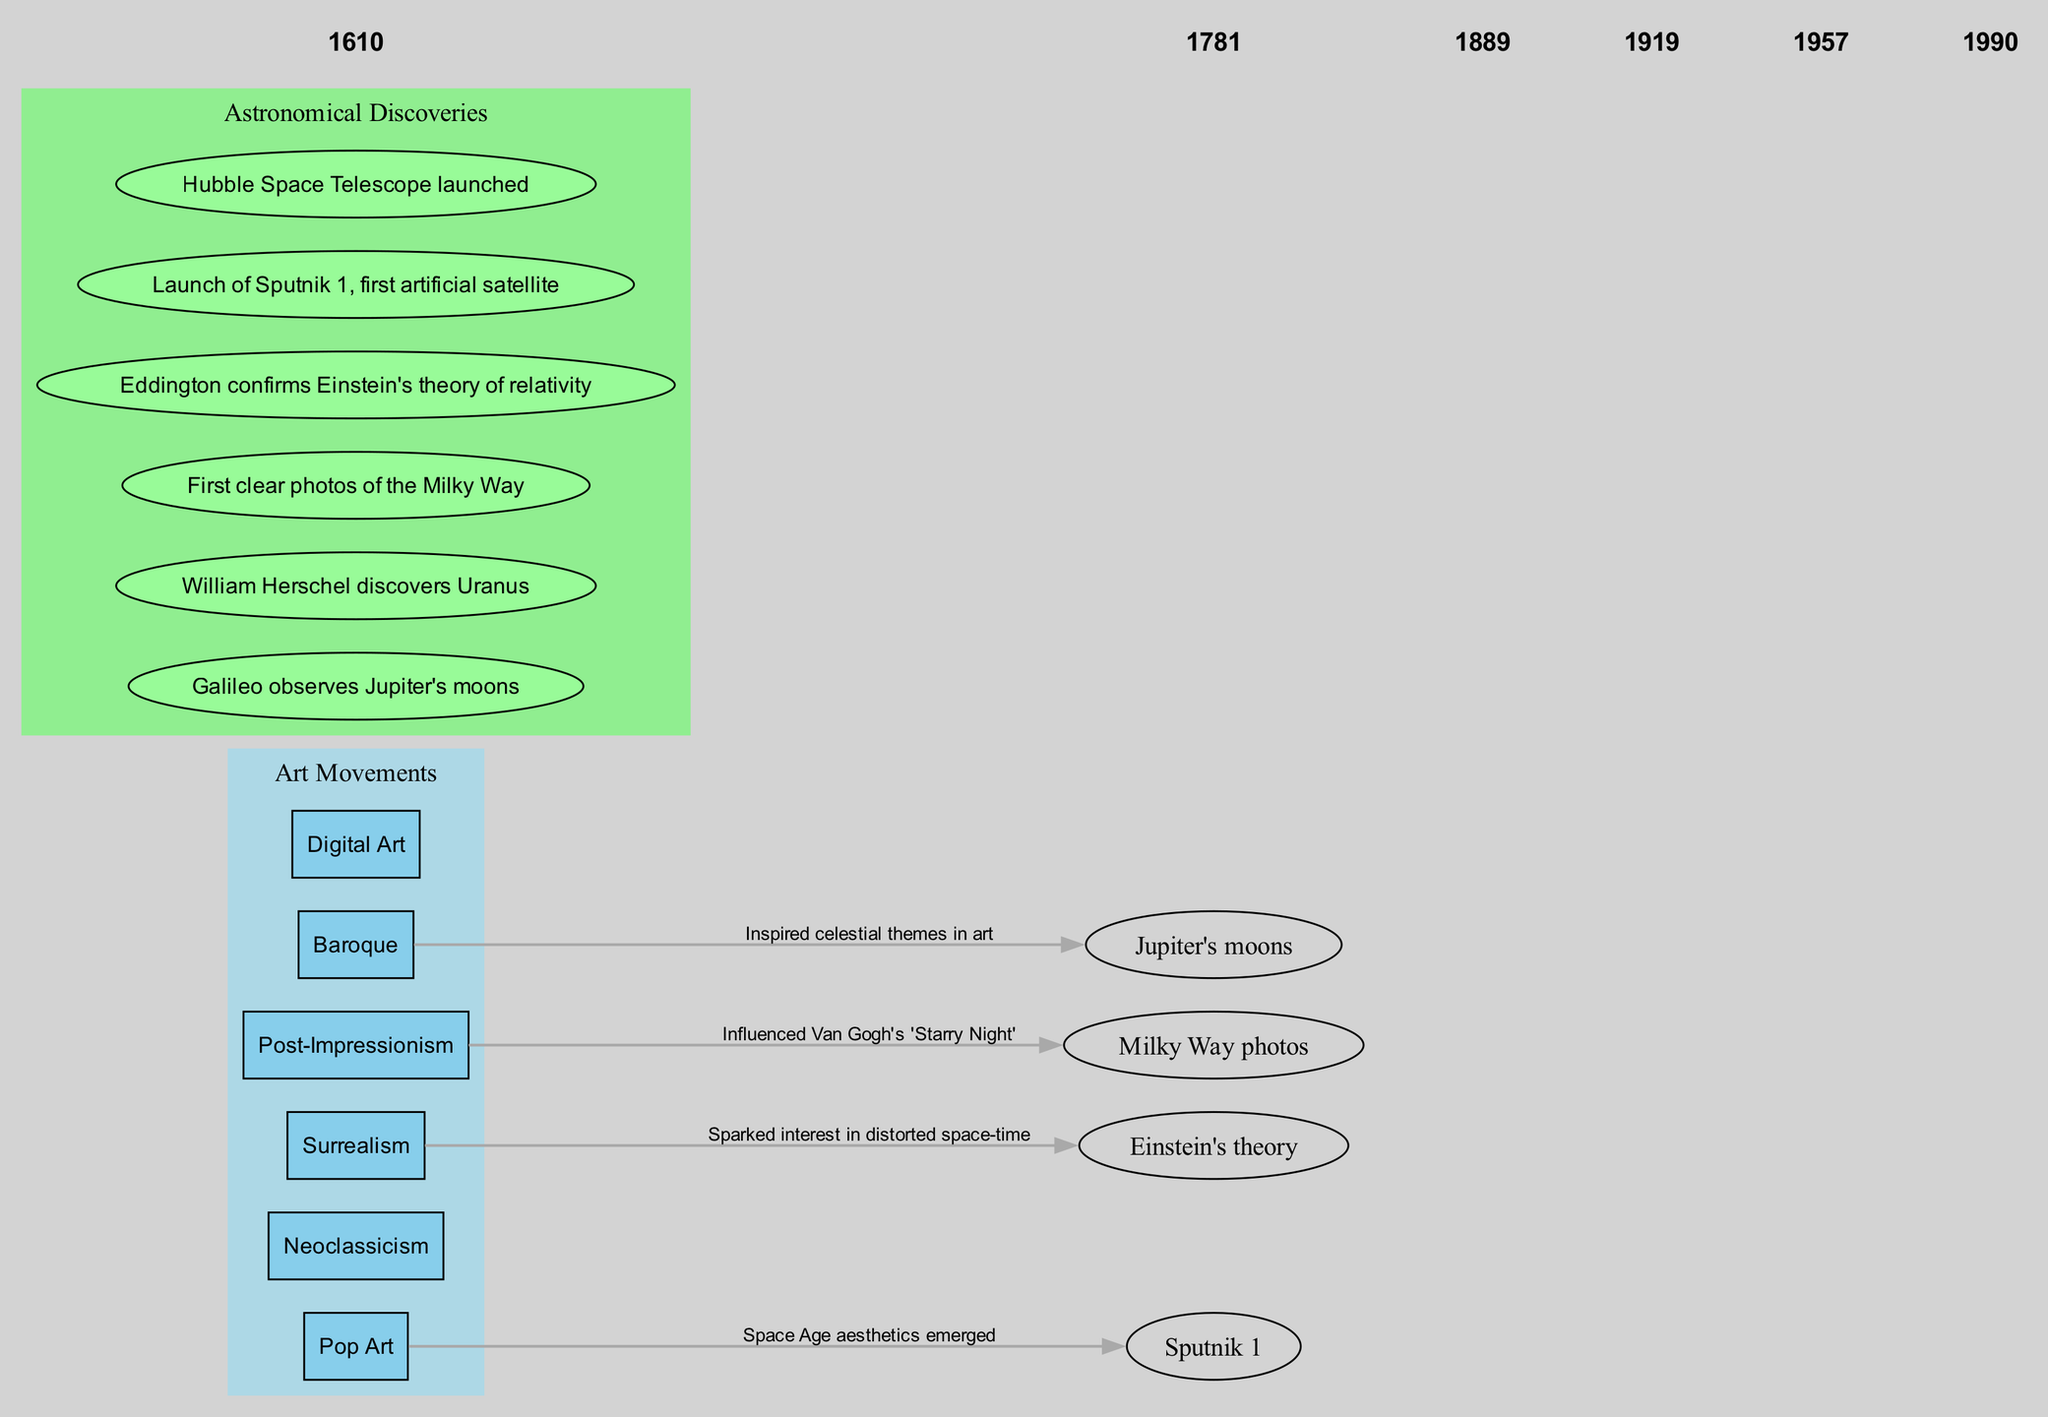What two astronomical discoveries are linked to Neoclassicism? By examining the connections in the diagram, we see that Neoclassicism is connected to the discovery of Uranus in 1781. There are no other discoveries linked to Neoclassicism in the timeline.
Answer: Uranus How many art movements are depicted in the diagram? The diagram lists six art movements: Baroque, Neoclassicism, Post-Impressionism, Surrealism, Pop Art, and Digital Art. By counting each movement from the timeline nodes, we find the total.
Answer: 6 What is the first astronomical discovery shown in the diagram? Looking at the timeline, the first year listed is 1610, which corresponds to Galileo observing Jupiter's moons. This is the earliest discovery mentioned.
Answer: Galileo observes Jupiter's moons Which art movement is associated with the launch of Sputnik 1? The connection indicates that Pop Art is associated with the launch of Sputnik 1 in 1957. This can be confirmed by locating the respective nodes in the diagram.
Answer: Pop Art Why does Post-Impressionism influence Van Gogh's 'Starry Night'? The diagram connects Post-Impressionism with the first clear photos of the Milky Way and suggests that this inspired Van Gogh's work. To answer, we look at the connections and the influence stated.
Answer: Inspired by the Milky Way photos What label is given to the connection between Surrealism and Einstein's theory of relativity? The connection from Surrealism to Einstein's theory is labeled as "Sparked interest in distorted space-time." We can find this label specifically in the connections section of the diagram.
Answer: Sparked interest in distorted space-time 